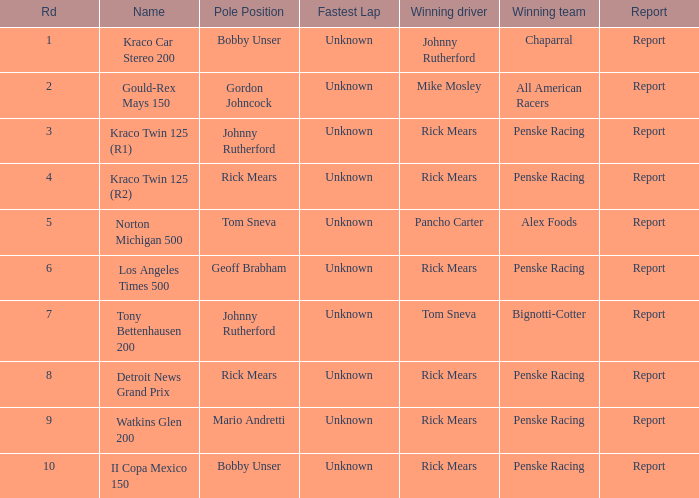The winning team of the race, los angeles times 500 is who? Penske Racing. 